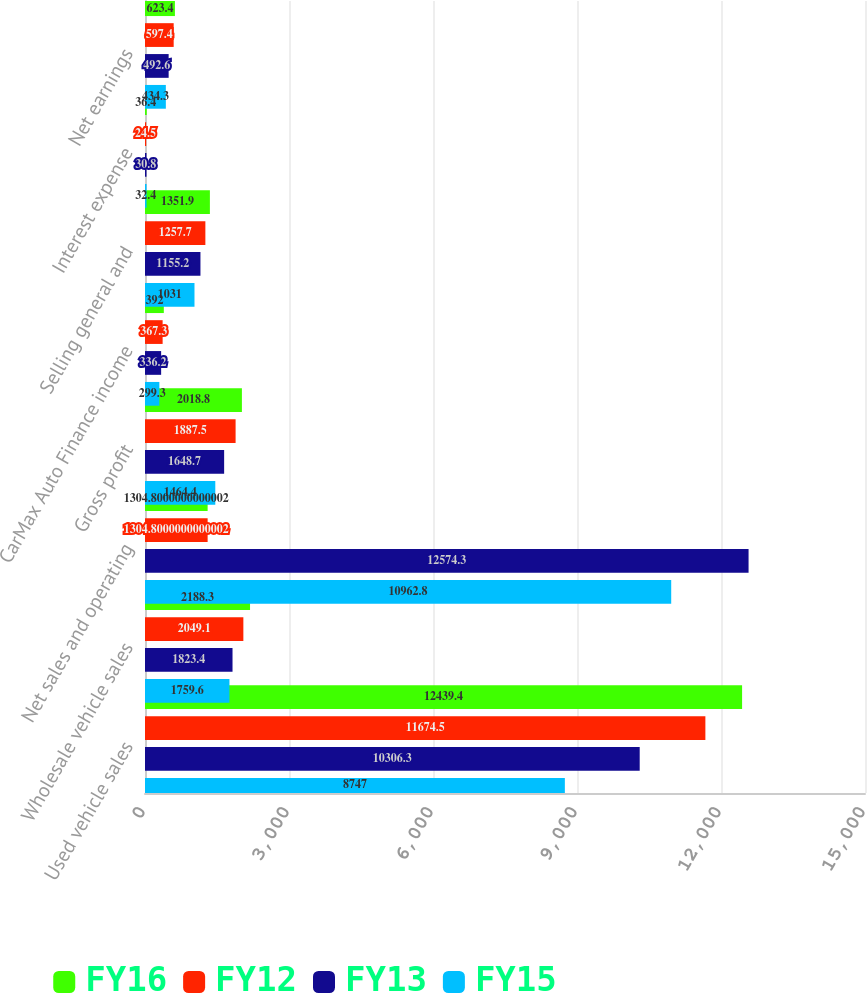<chart> <loc_0><loc_0><loc_500><loc_500><stacked_bar_chart><ecel><fcel>Used vehicle sales<fcel>Wholesale vehicle sales<fcel>Net sales and operating<fcel>Gross profit<fcel>CarMax Auto Finance income<fcel>Selling general and<fcel>Interest expense<fcel>Net earnings<nl><fcel>FY16<fcel>12439.4<fcel>2188.3<fcel>1304.8<fcel>2018.8<fcel>392<fcel>1351.9<fcel>36.4<fcel>623.4<nl><fcel>FY12<fcel>11674.5<fcel>2049.1<fcel>1304.8<fcel>1887.5<fcel>367.3<fcel>1257.7<fcel>24.5<fcel>597.4<nl><fcel>FY13<fcel>10306.3<fcel>1823.4<fcel>12574.3<fcel>1648.7<fcel>336.2<fcel>1155.2<fcel>30.8<fcel>492.6<nl><fcel>FY15<fcel>8747<fcel>1759.6<fcel>10962.8<fcel>1464.4<fcel>299.3<fcel>1031<fcel>32.4<fcel>434.3<nl></chart> 